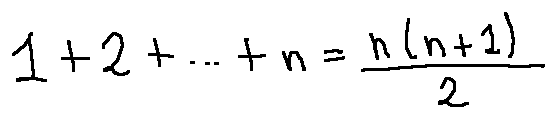<formula> <loc_0><loc_0><loc_500><loc_500>1 + 2 + \cdots + n = \frac { n ( n + 1 ) } { 2 }</formula> 